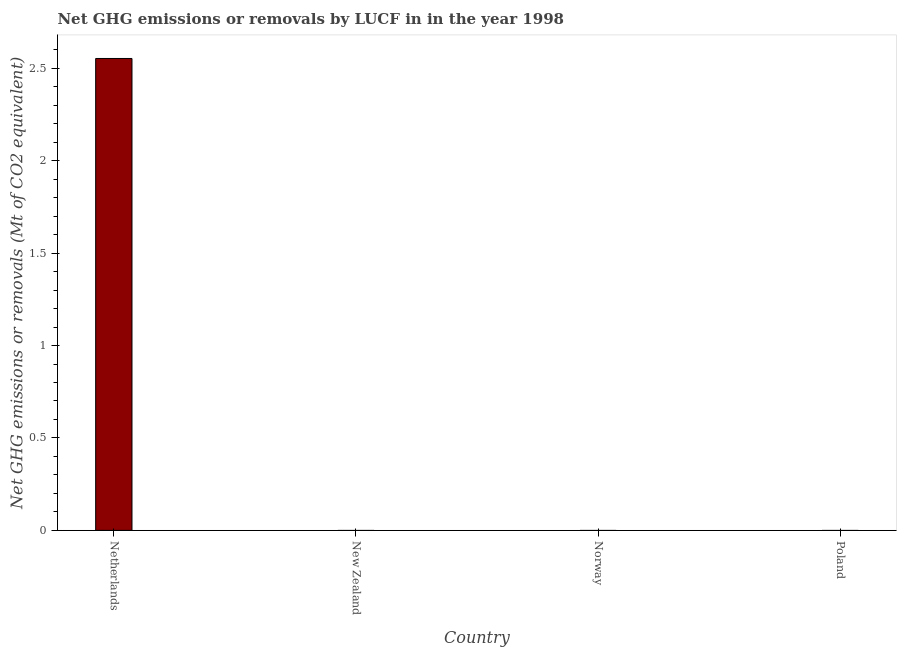Does the graph contain any zero values?
Your answer should be compact. Yes. What is the title of the graph?
Offer a very short reply. Net GHG emissions or removals by LUCF in in the year 1998. What is the label or title of the Y-axis?
Your answer should be compact. Net GHG emissions or removals (Mt of CO2 equivalent). What is the ghg net emissions or removals in Netherlands?
Give a very brief answer. 2.55. Across all countries, what is the maximum ghg net emissions or removals?
Provide a succinct answer. 2.55. In which country was the ghg net emissions or removals maximum?
Make the answer very short. Netherlands. What is the sum of the ghg net emissions or removals?
Provide a short and direct response. 2.55. What is the average ghg net emissions or removals per country?
Give a very brief answer. 0.64. What is the median ghg net emissions or removals?
Your answer should be very brief. 0. What is the difference between the highest and the lowest ghg net emissions or removals?
Your answer should be compact. 2.55. In how many countries, is the ghg net emissions or removals greater than the average ghg net emissions or removals taken over all countries?
Make the answer very short. 1. Are all the bars in the graph horizontal?
Offer a very short reply. No. What is the difference between two consecutive major ticks on the Y-axis?
Give a very brief answer. 0.5. What is the Net GHG emissions or removals (Mt of CO2 equivalent) in Netherlands?
Offer a terse response. 2.55. What is the Net GHG emissions or removals (Mt of CO2 equivalent) in New Zealand?
Ensure brevity in your answer.  0. 